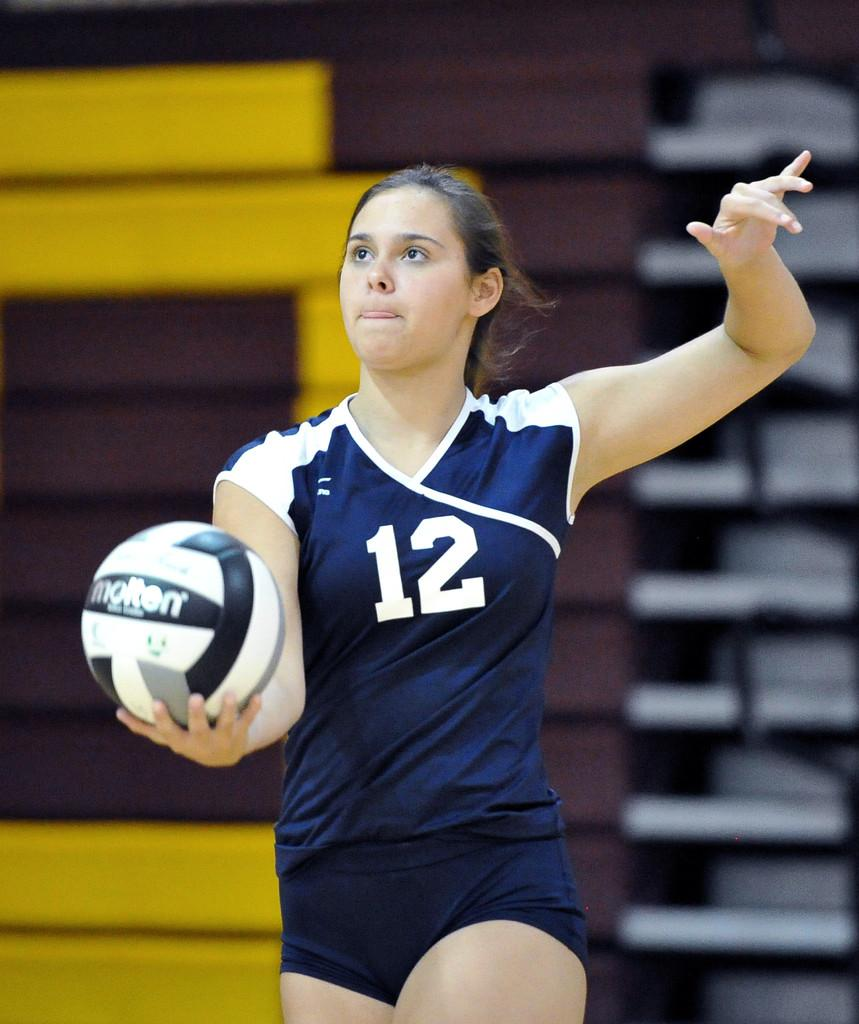Who is the main subject in the image? There is a woman in the image. What is the woman holding in the image? The woman is holding a volleyball. Can you describe the background of the image? The background of the image is blurred. Are there any objects visible in the background? Yes, there are objects visible in the background. What type of ornament is hanging from the woman's neck in the image? There is no ornament visible around the woman's neck in the image. How much ink is required to print the time on the volleyball in the image? There is no time printed on the volleyball in the image, and therefore no ink is required. 